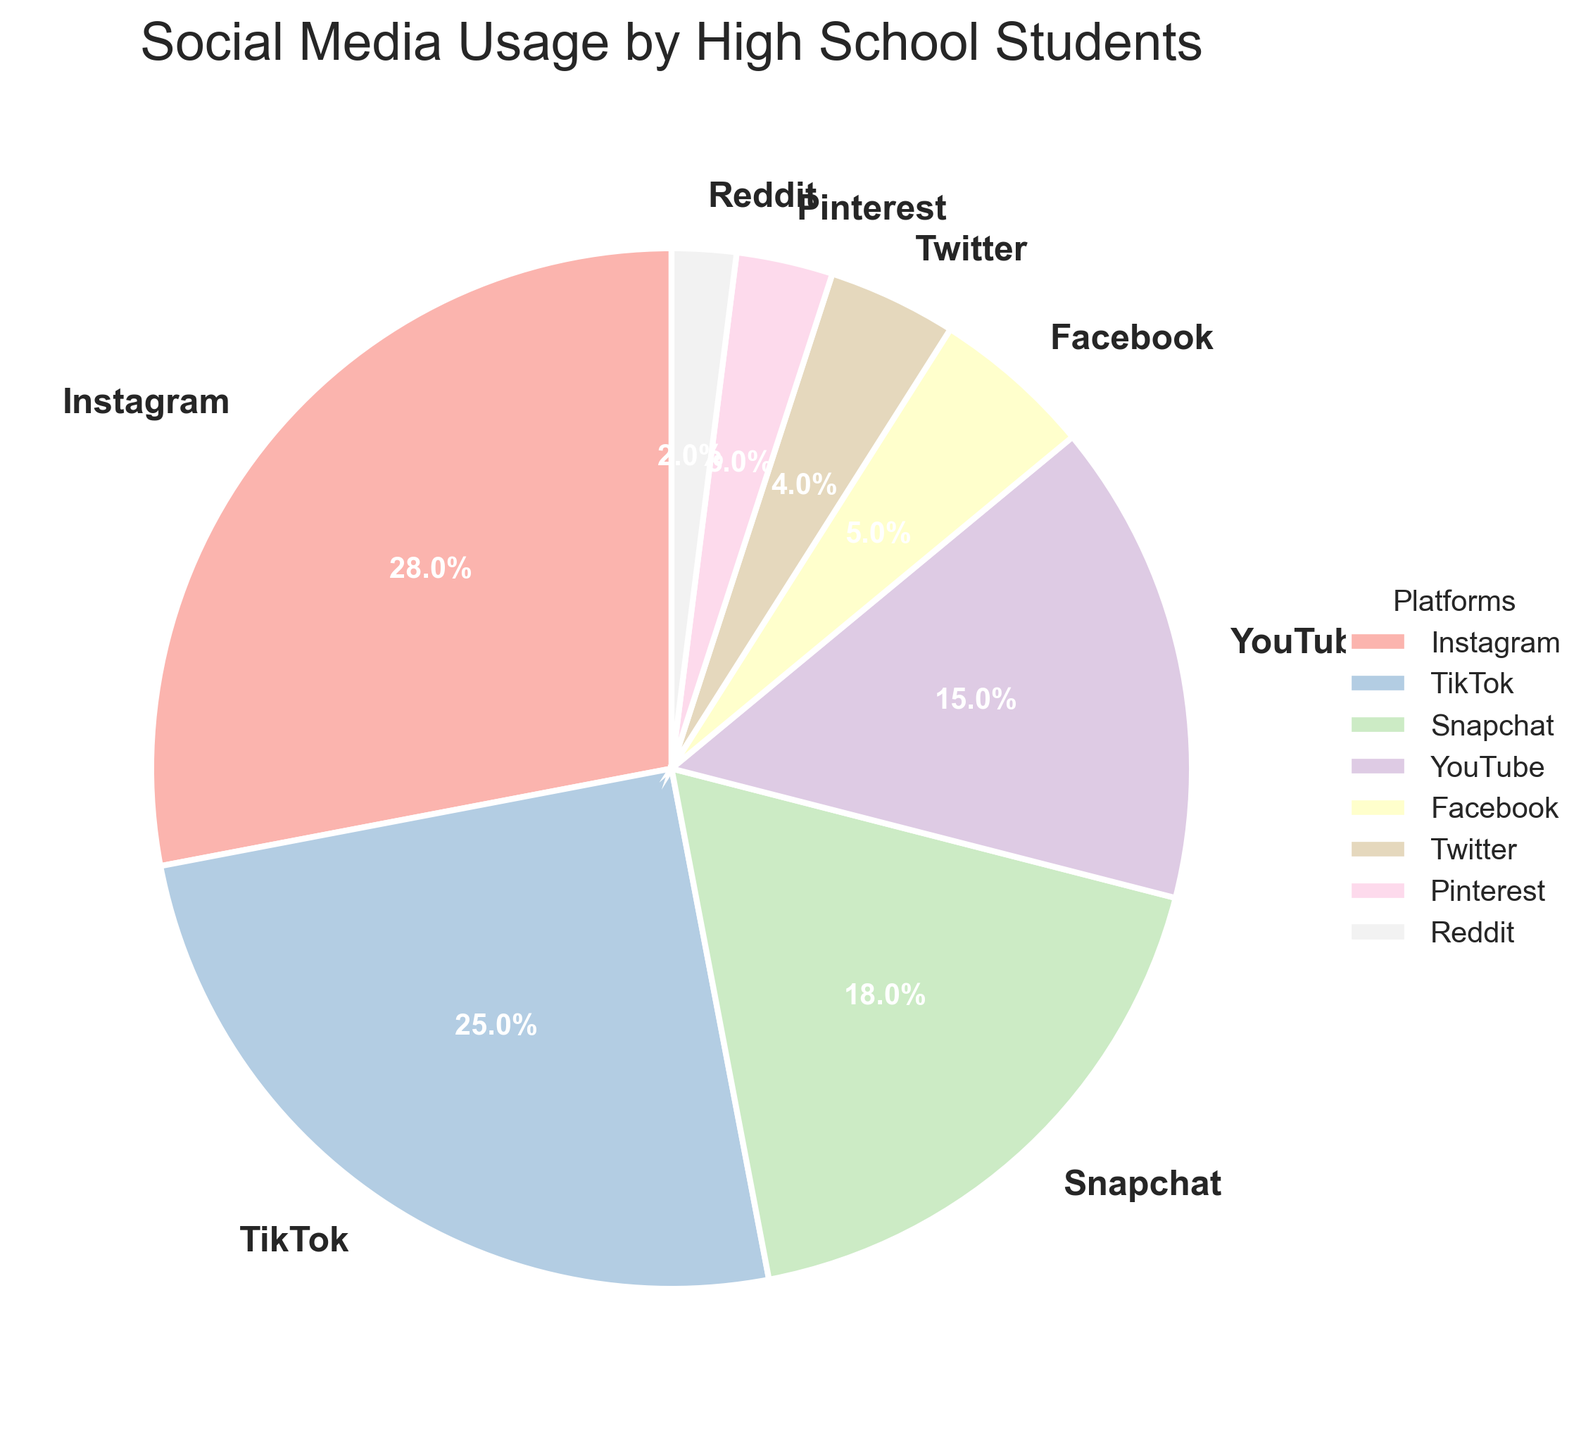What percentage of students spend time on Instagram? The label for Instagram in the pie chart shows the percentage of time students spend on this platform.
Answer: 28% Which platform do high school students use the least? By looking at the smallest slice in the pie chart, we can identify the platform with the lowest usage percentage.
Answer: Reddit How much more time do students spend on TikTok compared to YouTube? According to the pie chart, students spend 25% of their time on TikTok and 15% on YouTube. Subtracting these percentages (25% - 15%) gives the difference.
Answer: 10% What is the combined percentage of students using Facebook and Twitter? The pie chart shows that 5% of time is spent on Facebook and 4% on Twitter. Adding these percentages (5% + 4%) gives the combined usage.
Answer: 9% What is the most popular social media platform among high school students? The largest slice in the pie chart represents the platform with the highest percentage of usage.
Answer: Instagram Which two platforms combined have a similar usage to TikTok? TikTok usage is 25%. Looking at other platform percentages, YouTube and Snapchat (15% + 18%) sum to almost the same usage.
Answer: YouTube and Snapchat Which platforms are used by less than 10% of students each? Slices in the pie chart that show less than 10% usage are Reddit, Pinterest, Twitter, and Facebook.
Answer: Reddit, Pinterest, Twitter, and Facebook How many more percentage points do students use Instagram compared to Snapchat? The pie chart shows 28% usage for Instagram and 18% for Snapchat. Subtracting these percentages (28% - 18%) gives the difference.
Answer: 10% What is the average percentage use of Pinterest, Twitter, and Reddit combined? The percentages for Pinterest, Twitter, and Reddit are 3%, 4%, and 2% respectively. Summing them up and dividing by the number of platforms (3% + 4% + 2%) / 3 gives the average.
Answer: 3% What portion of the pie chart is made up by social media platforms that are not Instagram, TikTok or Snapchat? Subtract the combined percentage of Instagram, TikTok, and Snapchat (28% + 25% + 18%) from 100% to find the remaining portion of the pie chart.
Answer: 29% 